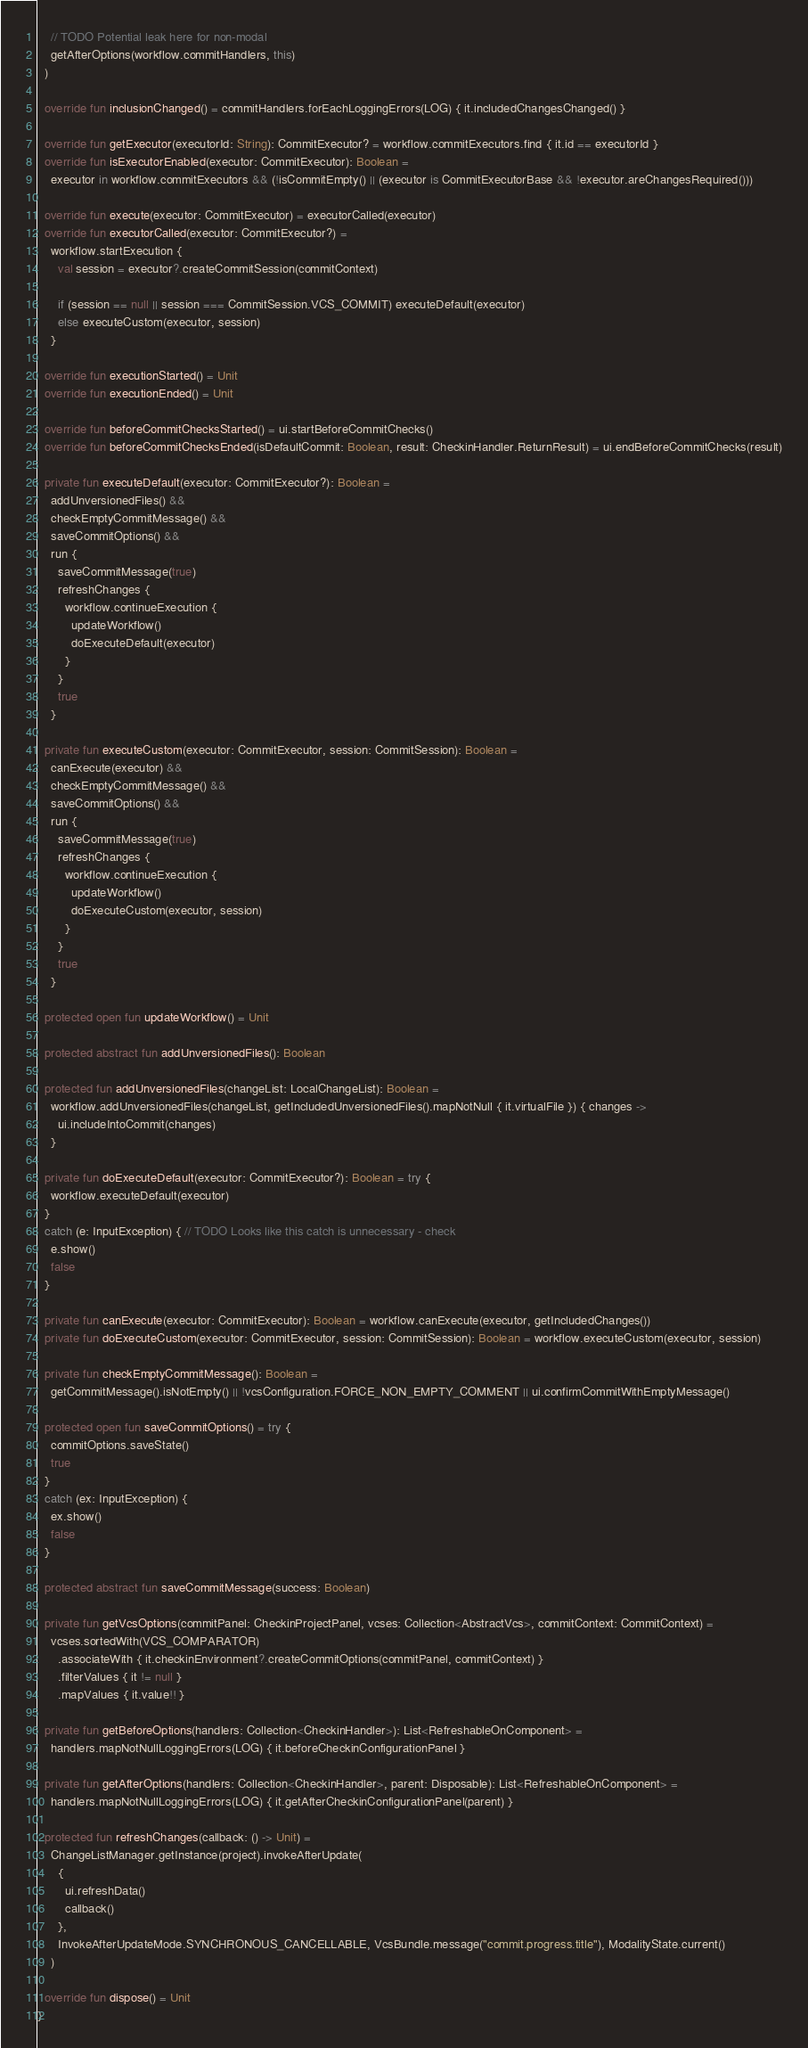<code> <loc_0><loc_0><loc_500><loc_500><_Kotlin_>    // TODO Potential leak here for non-modal
    getAfterOptions(workflow.commitHandlers, this)
  )

  override fun inclusionChanged() = commitHandlers.forEachLoggingErrors(LOG) { it.includedChangesChanged() }

  override fun getExecutor(executorId: String): CommitExecutor? = workflow.commitExecutors.find { it.id == executorId }
  override fun isExecutorEnabled(executor: CommitExecutor): Boolean =
    executor in workflow.commitExecutors && (!isCommitEmpty() || (executor is CommitExecutorBase && !executor.areChangesRequired()))

  override fun execute(executor: CommitExecutor) = executorCalled(executor)
  override fun executorCalled(executor: CommitExecutor?) =
    workflow.startExecution {
      val session = executor?.createCommitSession(commitContext)

      if (session == null || session === CommitSession.VCS_COMMIT) executeDefault(executor)
      else executeCustom(executor, session)
    }

  override fun executionStarted() = Unit
  override fun executionEnded() = Unit

  override fun beforeCommitChecksStarted() = ui.startBeforeCommitChecks()
  override fun beforeCommitChecksEnded(isDefaultCommit: Boolean, result: CheckinHandler.ReturnResult) = ui.endBeforeCommitChecks(result)

  private fun executeDefault(executor: CommitExecutor?): Boolean =
    addUnversionedFiles() &&
    checkEmptyCommitMessage() &&
    saveCommitOptions() &&
    run {
      saveCommitMessage(true)
      refreshChanges {
        workflow.continueExecution {
          updateWorkflow()
          doExecuteDefault(executor)
        }
      }
      true
    }

  private fun executeCustom(executor: CommitExecutor, session: CommitSession): Boolean =
    canExecute(executor) &&
    checkEmptyCommitMessage() &&
    saveCommitOptions() &&
    run {
      saveCommitMessage(true)
      refreshChanges {
        workflow.continueExecution {
          updateWorkflow()
          doExecuteCustom(executor, session)
        }
      }
      true
    }

  protected open fun updateWorkflow() = Unit

  protected abstract fun addUnversionedFiles(): Boolean

  protected fun addUnversionedFiles(changeList: LocalChangeList): Boolean =
    workflow.addUnversionedFiles(changeList, getIncludedUnversionedFiles().mapNotNull { it.virtualFile }) { changes ->
      ui.includeIntoCommit(changes)
    }

  private fun doExecuteDefault(executor: CommitExecutor?): Boolean = try {
    workflow.executeDefault(executor)
  }
  catch (e: InputException) { // TODO Looks like this catch is unnecessary - check
    e.show()
    false
  }

  private fun canExecute(executor: CommitExecutor): Boolean = workflow.canExecute(executor, getIncludedChanges())
  private fun doExecuteCustom(executor: CommitExecutor, session: CommitSession): Boolean = workflow.executeCustom(executor, session)

  private fun checkEmptyCommitMessage(): Boolean =
    getCommitMessage().isNotEmpty() || !vcsConfiguration.FORCE_NON_EMPTY_COMMENT || ui.confirmCommitWithEmptyMessage()

  protected open fun saveCommitOptions() = try {
    commitOptions.saveState()
    true
  }
  catch (ex: InputException) {
    ex.show()
    false
  }

  protected abstract fun saveCommitMessage(success: Boolean)

  private fun getVcsOptions(commitPanel: CheckinProjectPanel, vcses: Collection<AbstractVcs>, commitContext: CommitContext) =
    vcses.sortedWith(VCS_COMPARATOR)
      .associateWith { it.checkinEnvironment?.createCommitOptions(commitPanel, commitContext) }
      .filterValues { it != null }
      .mapValues { it.value!! }

  private fun getBeforeOptions(handlers: Collection<CheckinHandler>): List<RefreshableOnComponent> =
    handlers.mapNotNullLoggingErrors(LOG) { it.beforeCheckinConfigurationPanel }

  private fun getAfterOptions(handlers: Collection<CheckinHandler>, parent: Disposable): List<RefreshableOnComponent> =
    handlers.mapNotNullLoggingErrors(LOG) { it.getAfterCheckinConfigurationPanel(parent) }

  protected fun refreshChanges(callback: () -> Unit) =
    ChangeListManager.getInstance(project).invokeAfterUpdate(
      {
        ui.refreshData()
        callback()
      },
      InvokeAfterUpdateMode.SYNCHRONOUS_CANCELLABLE, VcsBundle.message("commit.progress.title"), ModalityState.current()
    )

  override fun dispose() = Unit
}</code> 